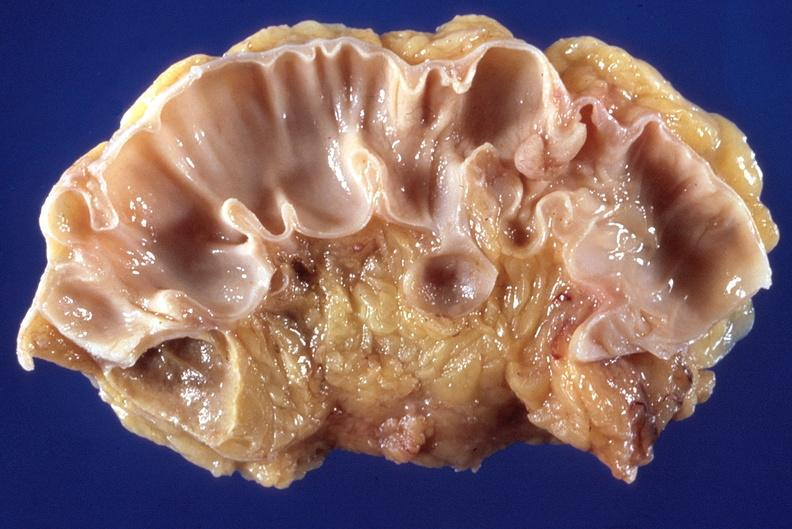does this image show sigmoid colon, diverticulosis and polyp?
Answer the question using a single word or phrase. Yes 